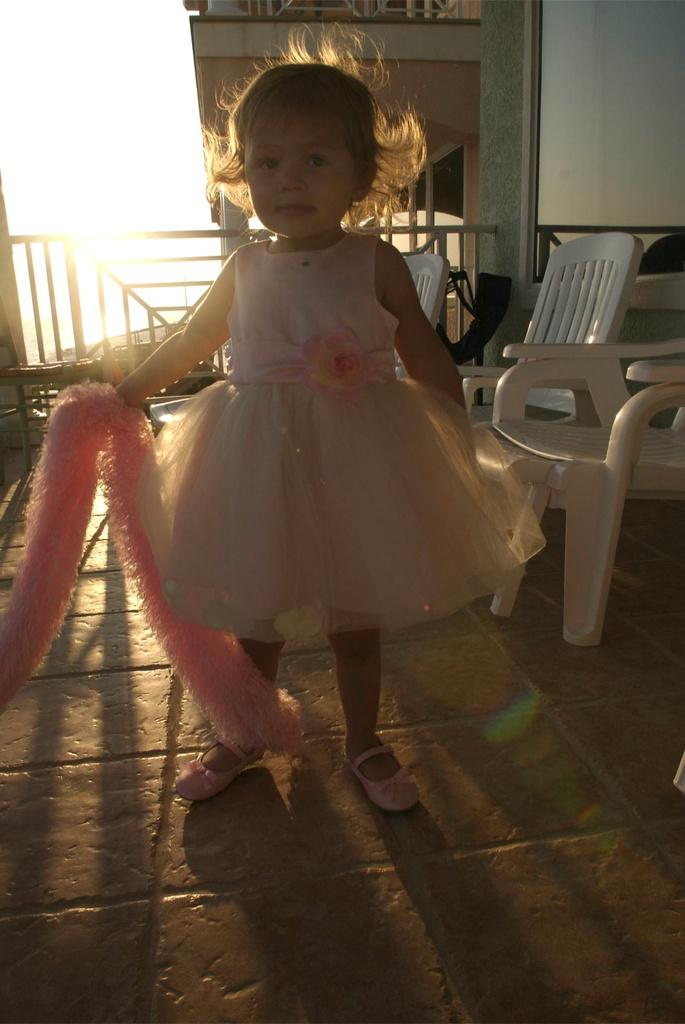What is the main subject of the picture? The main subject of the picture is a small girl. What is the girl doing in the picture? The girl is standing in the picture. What color is the girl's outfit? The girl is dressed in pink. What can be seen in the background of the picture? There are chairs in the background of the picture. What type of substance is the girl holding in her hand in the picture? There is no substance visible in the girl's hand in the picture. Does the girl have a tail in the picture? No, the girl does not have a tail in the picture. 